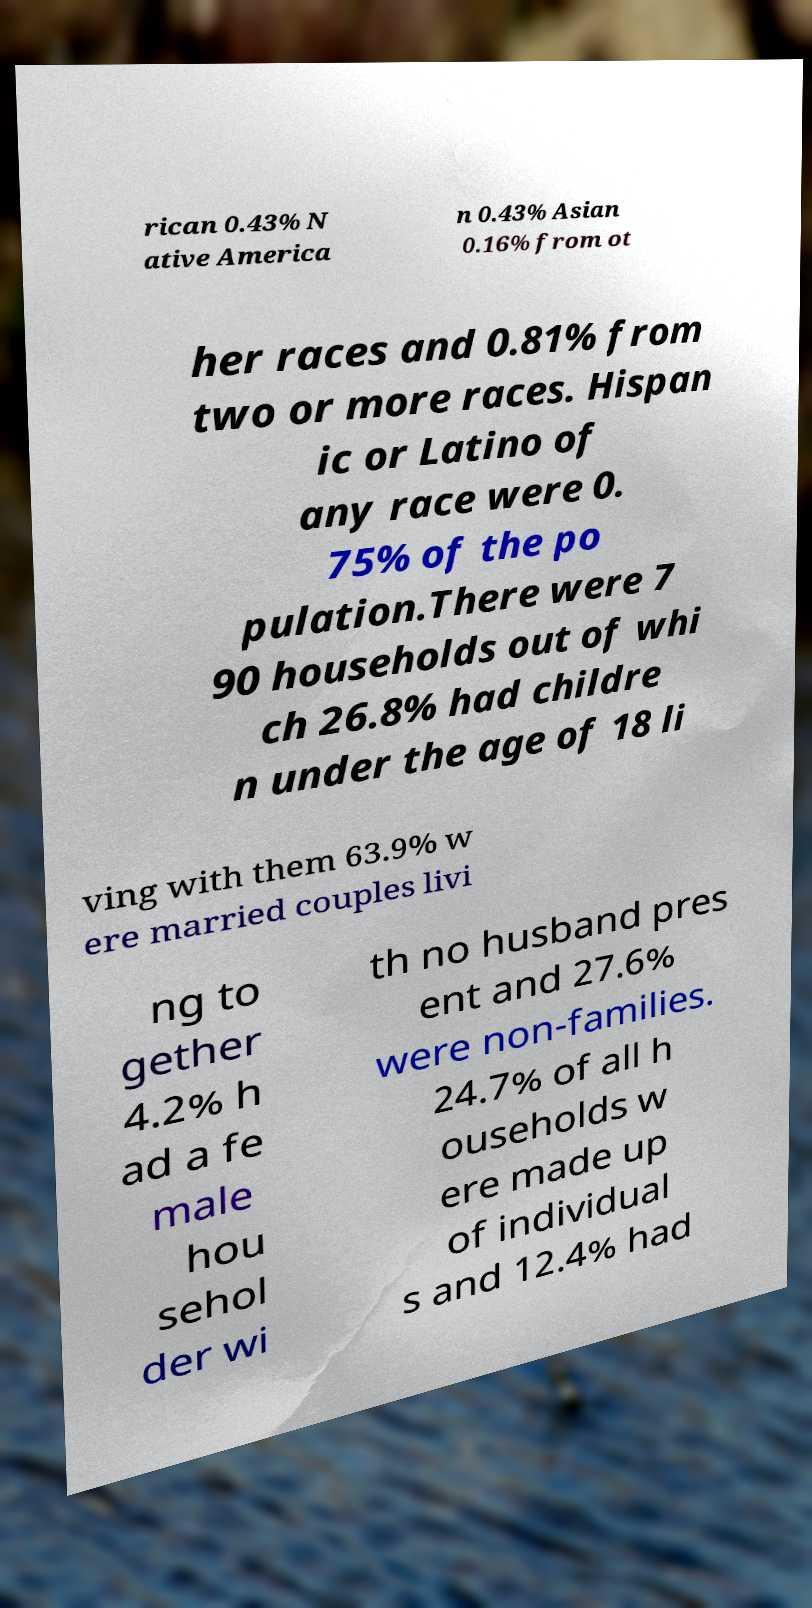There's text embedded in this image that I need extracted. Can you transcribe it verbatim? rican 0.43% N ative America n 0.43% Asian 0.16% from ot her races and 0.81% from two or more races. Hispan ic or Latino of any race were 0. 75% of the po pulation.There were 7 90 households out of whi ch 26.8% had childre n under the age of 18 li ving with them 63.9% w ere married couples livi ng to gether 4.2% h ad a fe male hou sehol der wi th no husband pres ent and 27.6% were non-families. 24.7% of all h ouseholds w ere made up of individual s and 12.4% had 